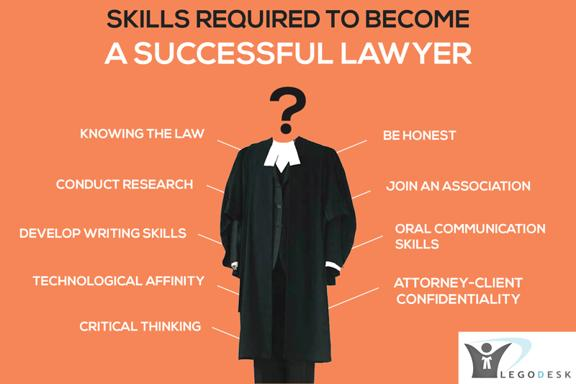Can you elaborate on the importance of 'Technological Affinity' for lawyers as mentioned in the image? Technological affinity is increasingly vital for lawyers due to the growing reliance on digital tools for legal research, case management, and client communication. Proficiency in technology helps lawyers streamline their workflow, enhance data security, and stay updated with current laws and precedents through online databases. This skill also aids in virtual courtroom proceedings, which have become more prevalent. 